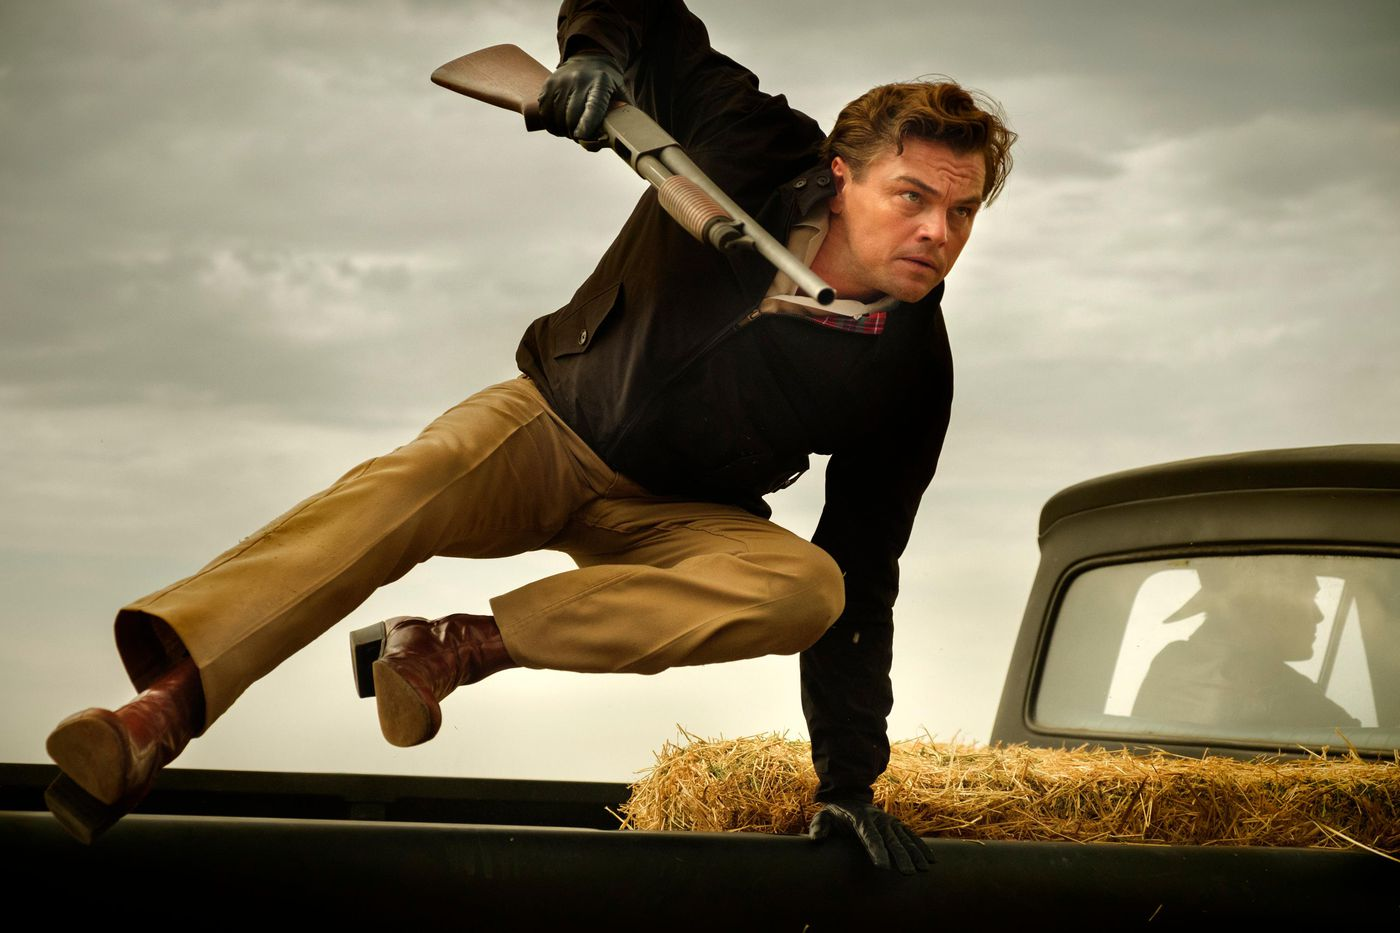What might be the context or storyline hinted at in this image? This image seems to depict a moment of action or escape, likely from a thriller or action movie. The man's outfit and the vintage car set against a rural landscape could hint at a storyline involving a chase or a showdown in a countryside setting, where the character is either fleeing danger or heading towards a crucial confrontation. 